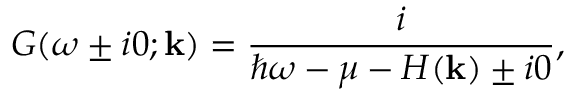Convert formula to latex. <formula><loc_0><loc_0><loc_500><loc_500>G ( \omega \pm i 0 ; k ) = \frac { i } { \hbar { \omega } - \mu - H ( k ) \pm i 0 } ,</formula> 